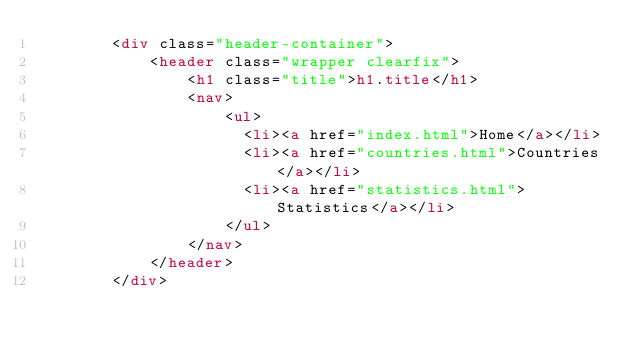Convert code to text. <code><loc_0><loc_0><loc_500><loc_500><_HTML_>        <div class="header-container">
            <header class="wrapper clearfix">
                <h1 class="title">h1.title</h1>
                <nav>
                    <ul>
                      <li><a href="index.html">Home</a></li>
                      <li><a href="countries.html">Countries</a></li>
                      <li><a href="statistics.html">Statistics</a></li>
                    </ul>
                </nav>
            </header>
        </div>
</code> 